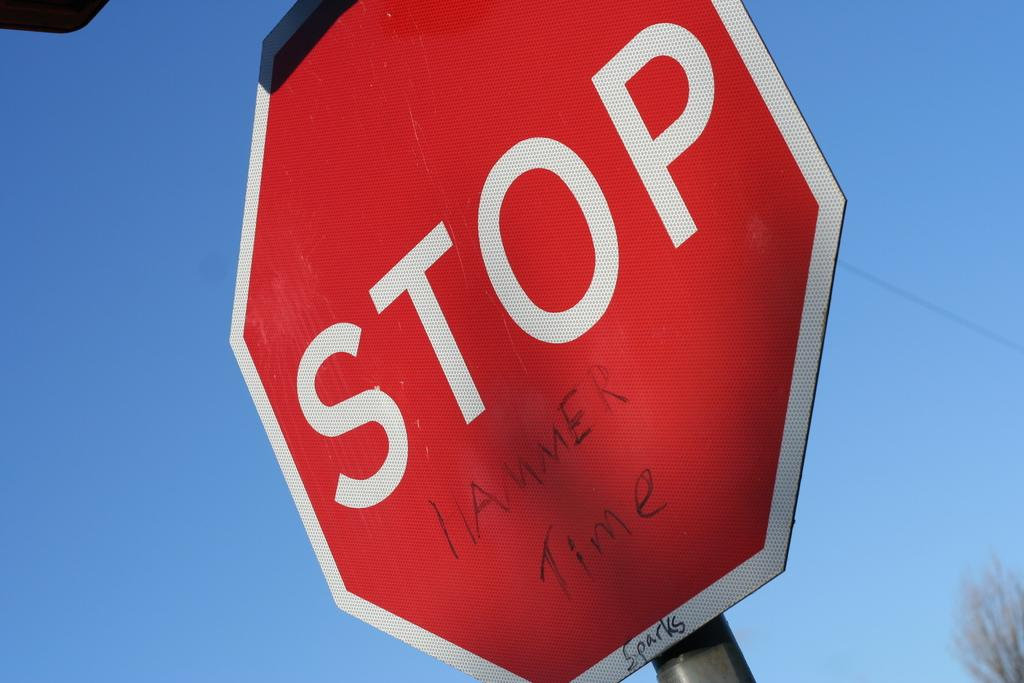<image>
Provide a brief description of the given image. The words hammer time are written on a stop sign. 